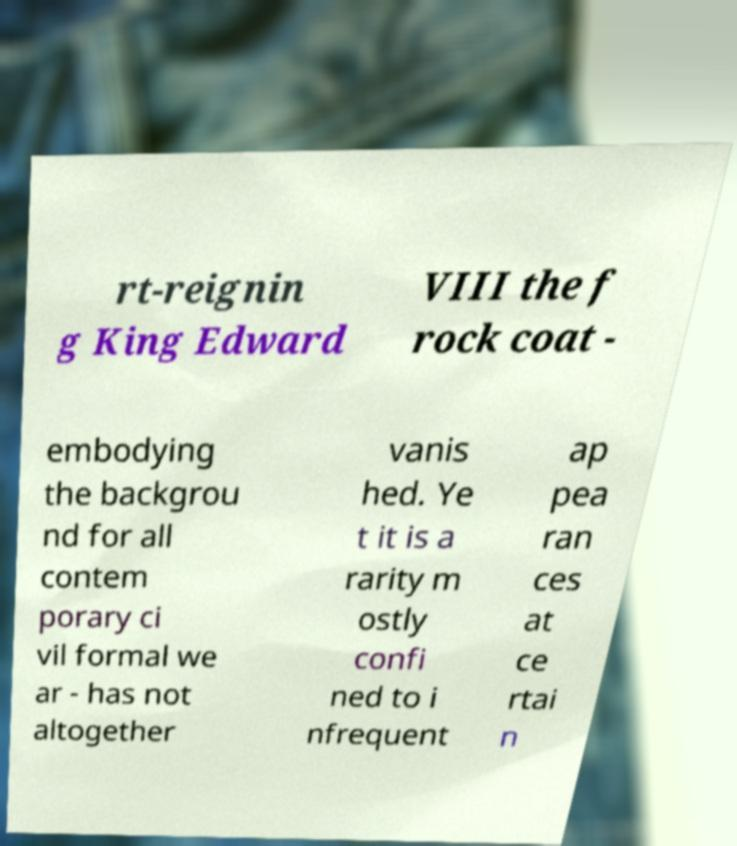What messages or text are displayed in this image? I need them in a readable, typed format. rt-reignin g King Edward VIII the f rock coat - embodying the backgrou nd for all contem porary ci vil formal we ar - has not altogether vanis hed. Ye t it is a rarity m ostly confi ned to i nfrequent ap pea ran ces at ce rtai n 